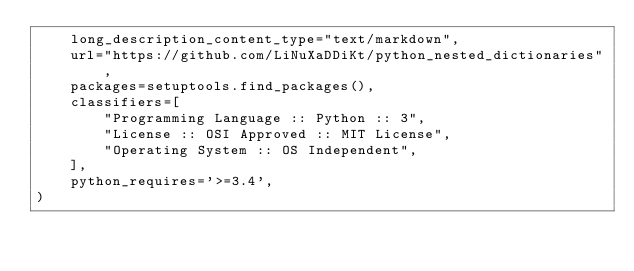Convert code to text. <code><loc_0><loc_0><loc_500><loc_500><_Python_>    long_description_content_type="text/markdown",
    url="https://github.com/LiNuXaDDiKt/python_nested_dictionaries",
    packages=setuptools.find_packages(),
    classifiers=[
        "Programming Language :: Python :: 3",
        "License :: OSI Approved :: MIT License",
        "Operating System :: OS Independent",
    ],
    python_requires='>=3.4',
)
</code> 